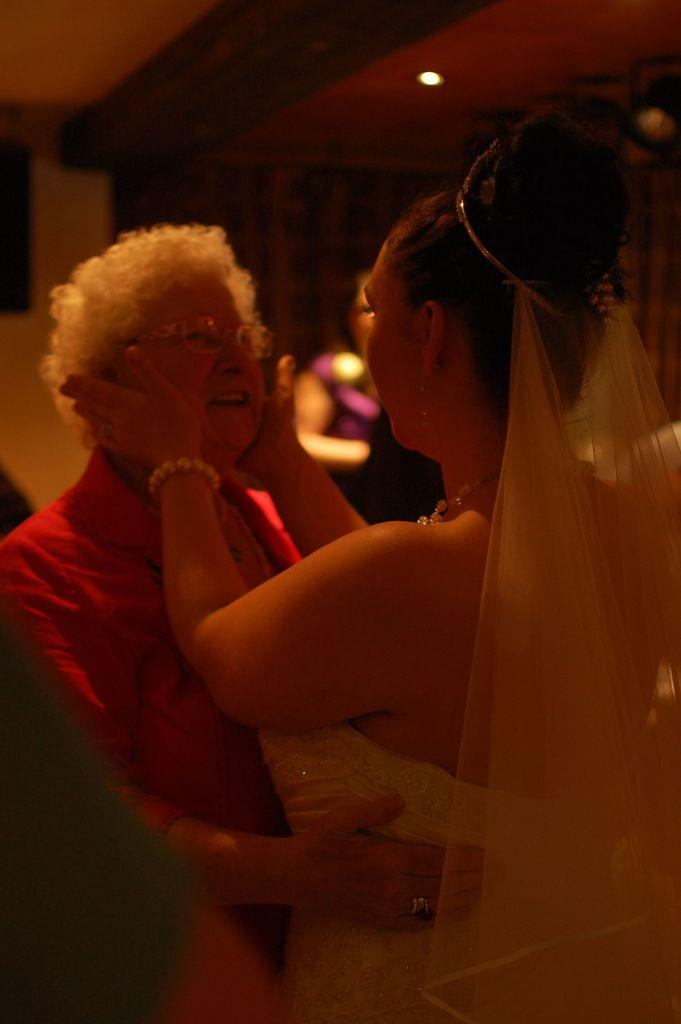How many women are in the image? There are two women in the image. Can you describe one of the women's appearance? One of the women is wearing glasses (specs). What else can be seen in the image besides the two women? There is a person in the background of the image and a light on the ceiling. What type of square-shaped berry can be seen on the table in the image? There is no square-shaped berry present in the image. 